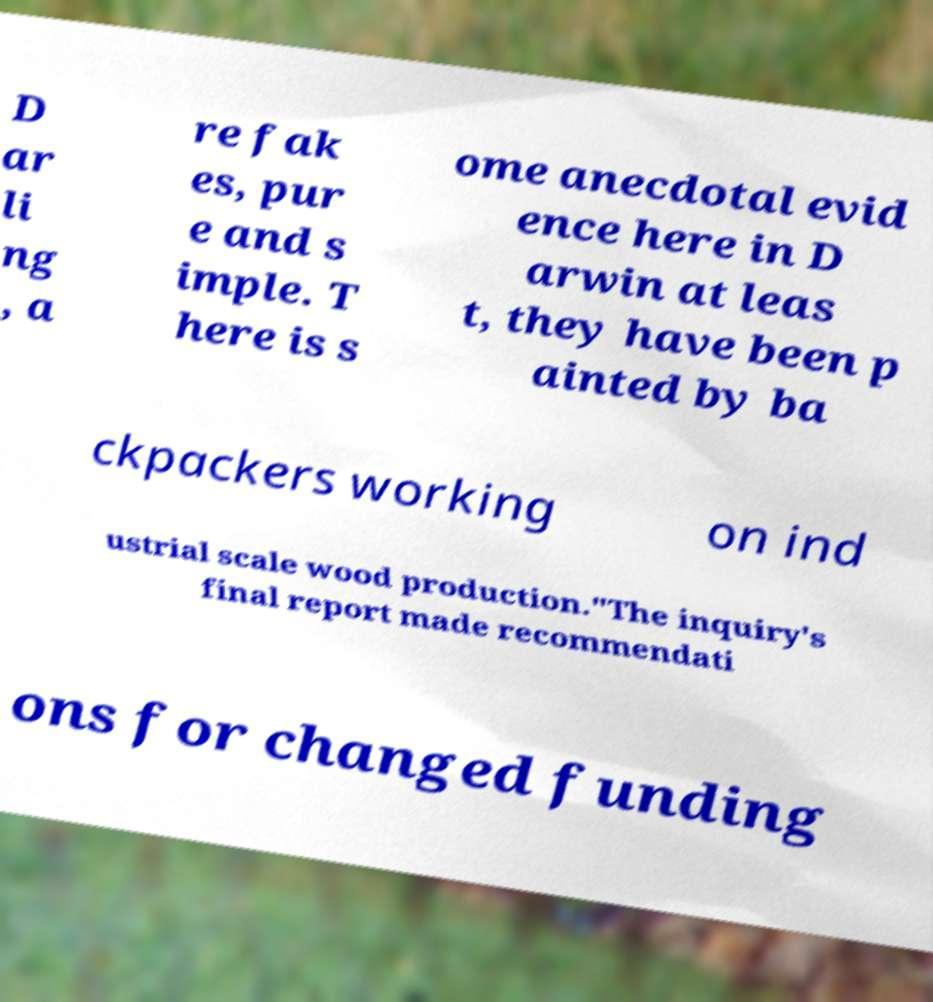Please read and relay the text visible in this image. What does it say? D ar li ng , a re fak es, pur e and s imple. T here is s ome anecdotal evid ence here in D arwin at leas t, they have been p ainted by ba ckpackers working on ind ustrial scale wood production."The inquiry's final report made recommendati ons for changed funding 